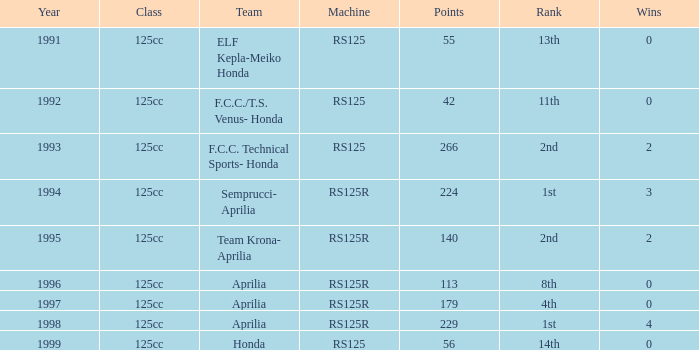Which team had a year over 1995, machine of RS125R, and ranked 1st? Aprilia. 